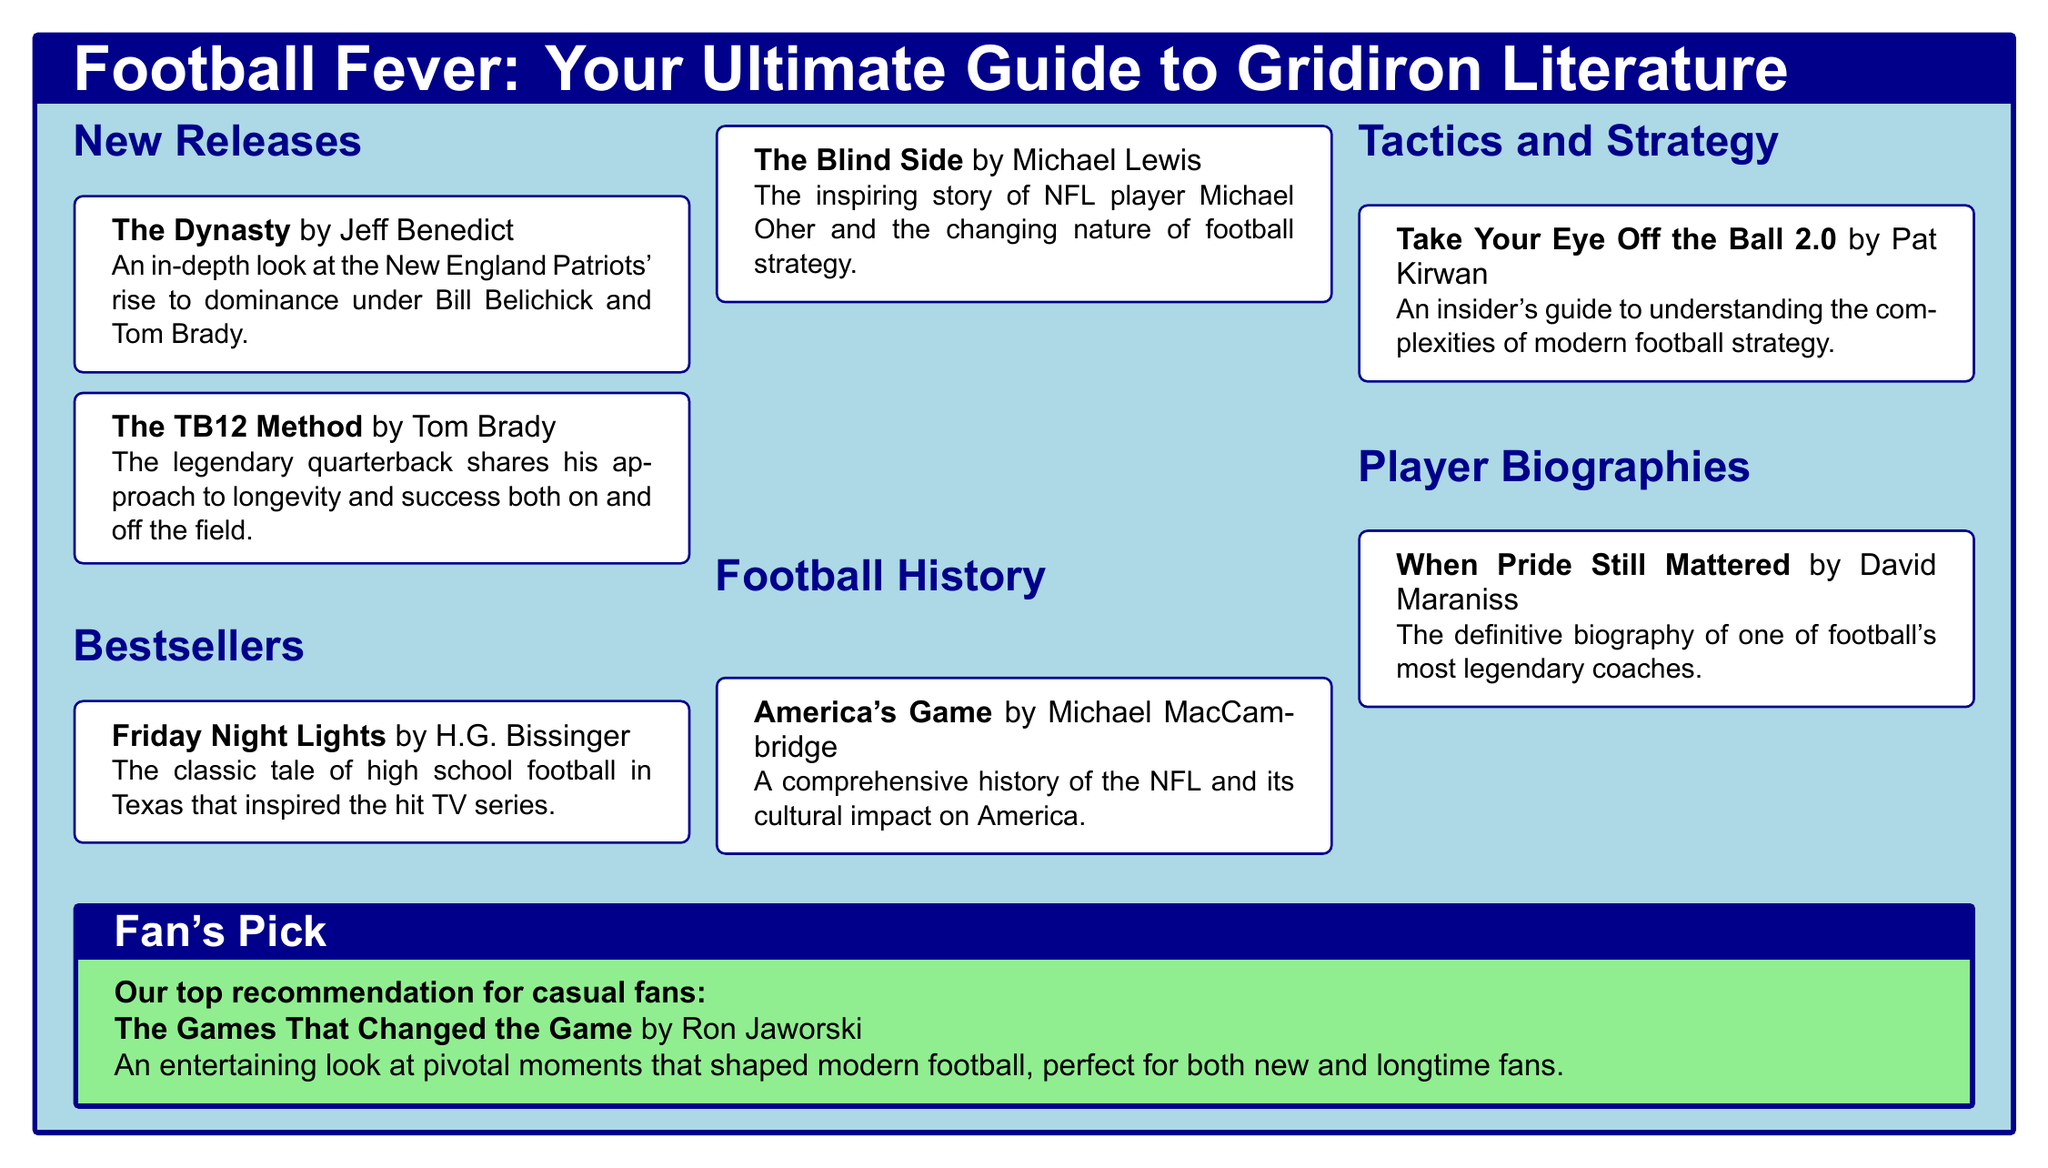What is the title of the new release by Jeff Benedict? The title provided in the new releases section is "The Dynasty" by Jeff Benedict.
Answer: The Dynasty Who is the author of "The Blind Side"? The document lists Michael Lewis as the author of "The Blind Side" in the bestsellers section.
Answer: Michael Lewis Which book is recommended for casual fans? The fan's pick section highlights "The Games That Changed the Game" by Ron Jaworski as the top recommendation for casual fans.
Answer: The Games That Changed the Game What subject does "Take Your Eye Off the Ball 2.0" focus on? The title in the tactics and strategy section suggests it is an insider's guide to understanding football strategy.
Answer: Tactics and Strategy Who wrote the biography titled "When Pride Still Mattered"? The document indicates that David Maraniss is the author of "When Pride Still Mattered" in the player biographies section.
Answer: David Maraniss How many sections are there in this catalog? The catalog contains five sections: New Releases, Bestsellers, Football History, Tactics and Strategy, and Player Biographies.
Answer: Five What is the primary theme of "Friday Night Lights"? The book "Friday Night Lights" is described as a classic tale of high school football in Texas.
Answer: High school football Is "The TB12 Method" a new release or a bestseller? The title "The TB12 Method" is categorized under new releases in the document.
Answer: New Release 